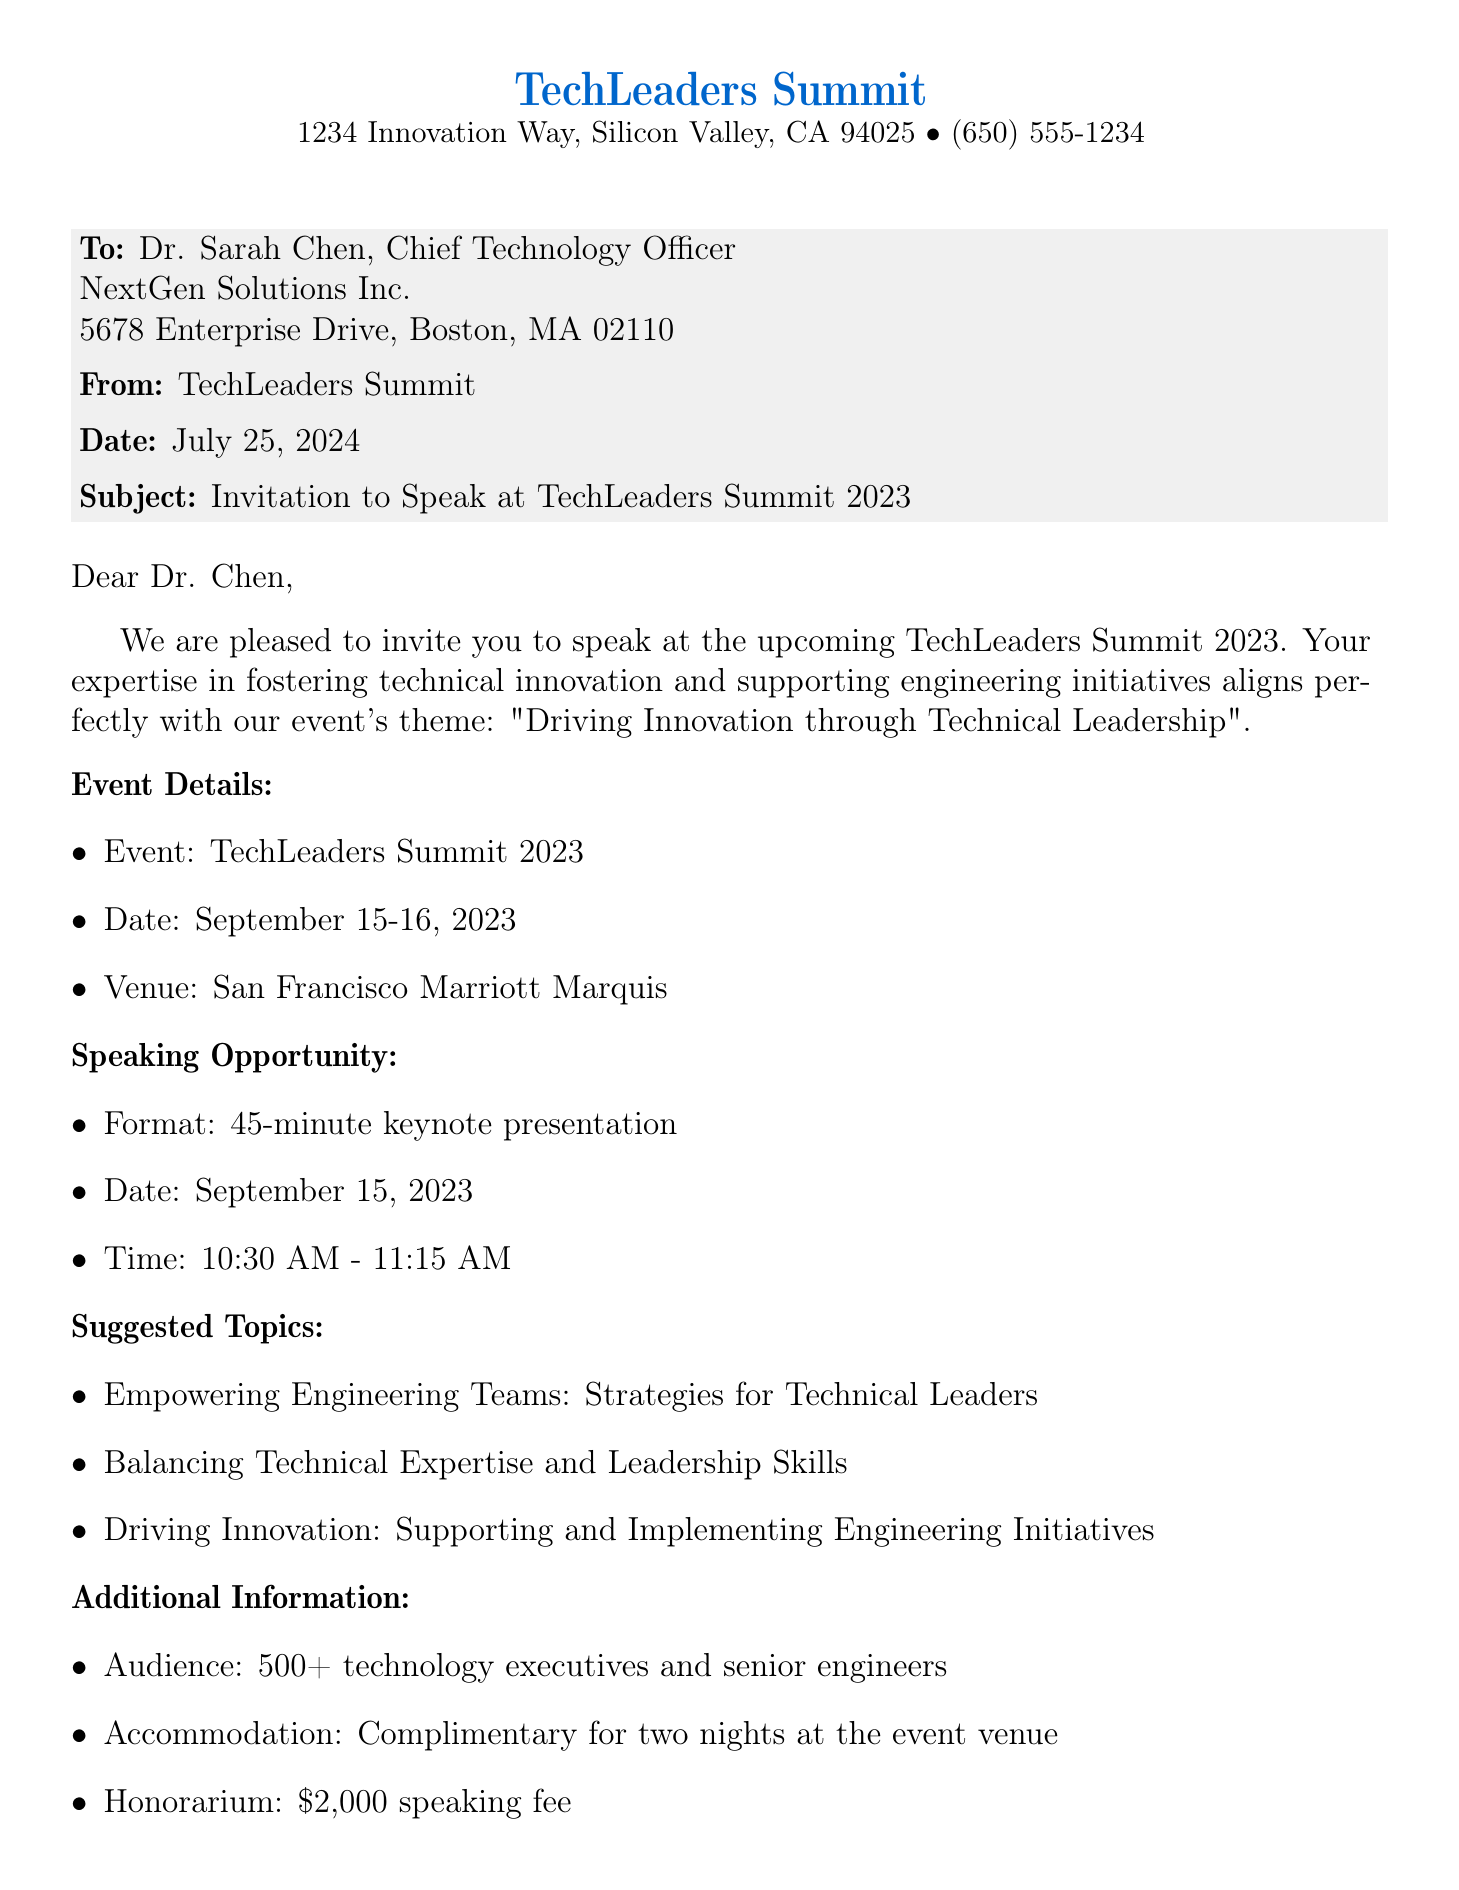What is the event name? The event name is stated at the beginning of the document.
Answer: TechLeaders Summit 2023 What are the event dates? The document specifies the event dates in the event details section.
Answer: September 15-16, 2023 What is the speaking fee? The honorarium for speaking is mentioned in the additional information section.
Answer: $2,000 What is the speaking format? The document describes the format of the speaking opportunity.
Answer: 45-minute keynote presentation Who should be contacted for questions? The document provides contact information for event inquiries.
Answer: Emily Watson What time is the keynote presentation scheduled? The specific time for the keynote is given in the speaking opportunity section.
Answer: 10:30 AM - 11:15 AM What is the audience size expected at the event? The audience size is noted in the additional information.
Answer: 500+ Where will the event take place? The venue for the event is listed in the event details.
Answer: San Francisco Marriott Marquis What is the deadline to confirm participation? The last date for confirmation is provided in the document.
Answer: July 31, 2023 